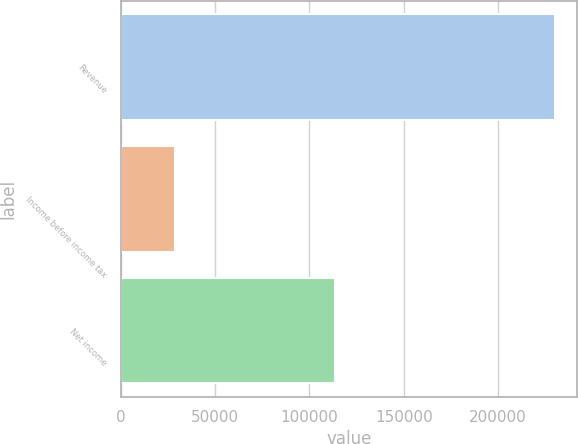Convert chart to OTSL. <chart><loc_0><loc_0><loc_500><loc_500><bar_chart><fcel>Revenue<fcel>Income before income tax<fcel>Net income<nl><fcel>230323<fcel>28871<fcel>113794<nl></chart> 